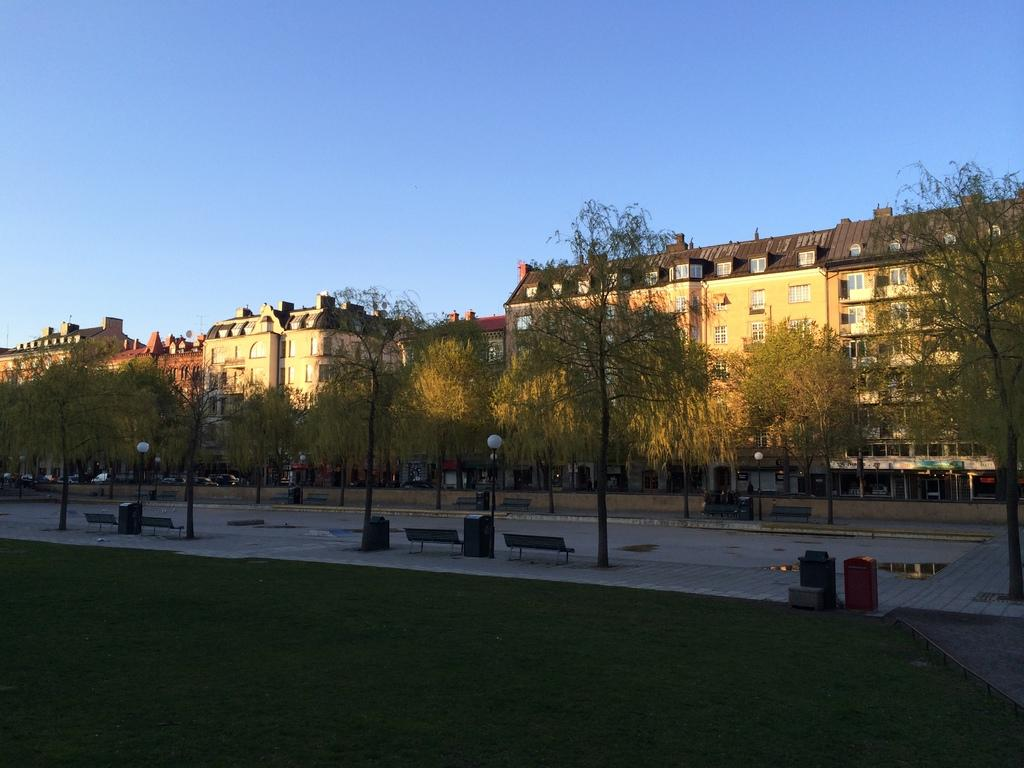What type of vegetation is present in the image? There is grass in the image. What other natural elements can be seen in the image? There are trees in the image. What type of seating is available in the image? There are benches in the image. What man-made structures are present in the image? There are poles in the image. What can be seen in the background of the image? There are buildings and the sky visible in the background of the image. What colors are the buildings in the image? The buildings are cream and brown in color. Can you see a volleyball game being played in the image? There is no volleyball game present in the image. What type of tail is attached to the buildings in the image? There are no tails attached to the buildings in the image; they are simply structures with cream and brown colors. 